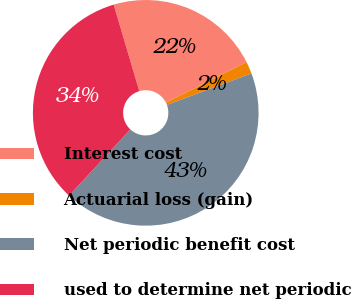<chart> <loc_0><loc_0><loc_500><loc_500><pie_chart><fcel>Interest cost<fcel>Actuarial loss (gain)<fcel>Net periodic benefit cost<fcel>used to determine net periodic<nl><fcel>22.16%<fcel>1.75%<fcel>42.57%<fcel>33.53%<nl></chart> 